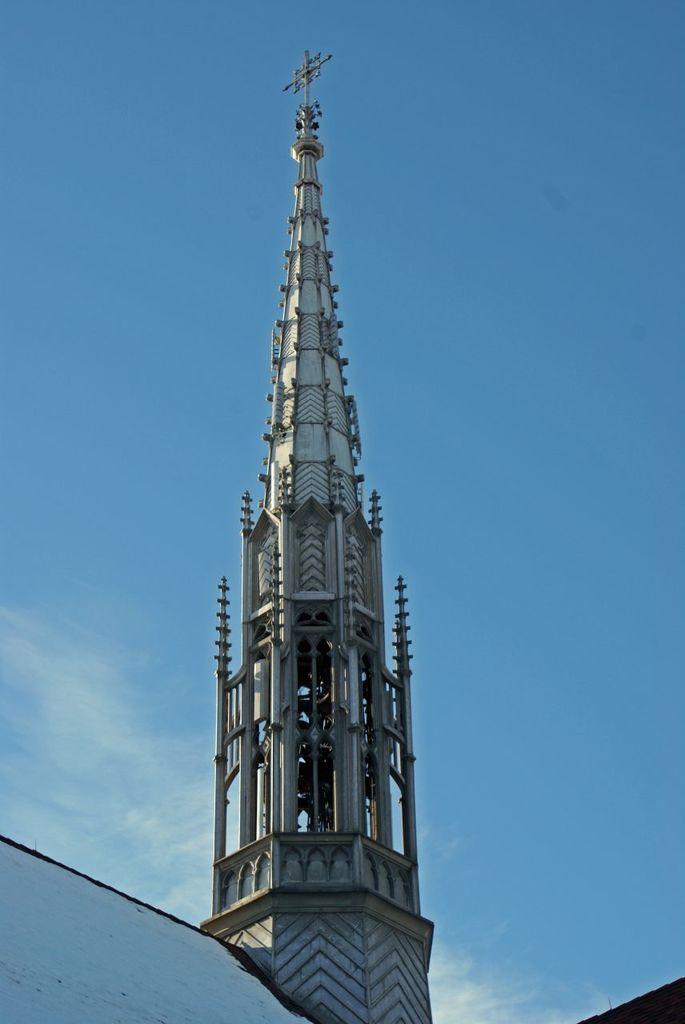Please provide a concise description of this image. In this picture I can see a tower, and in the background there is sky. 